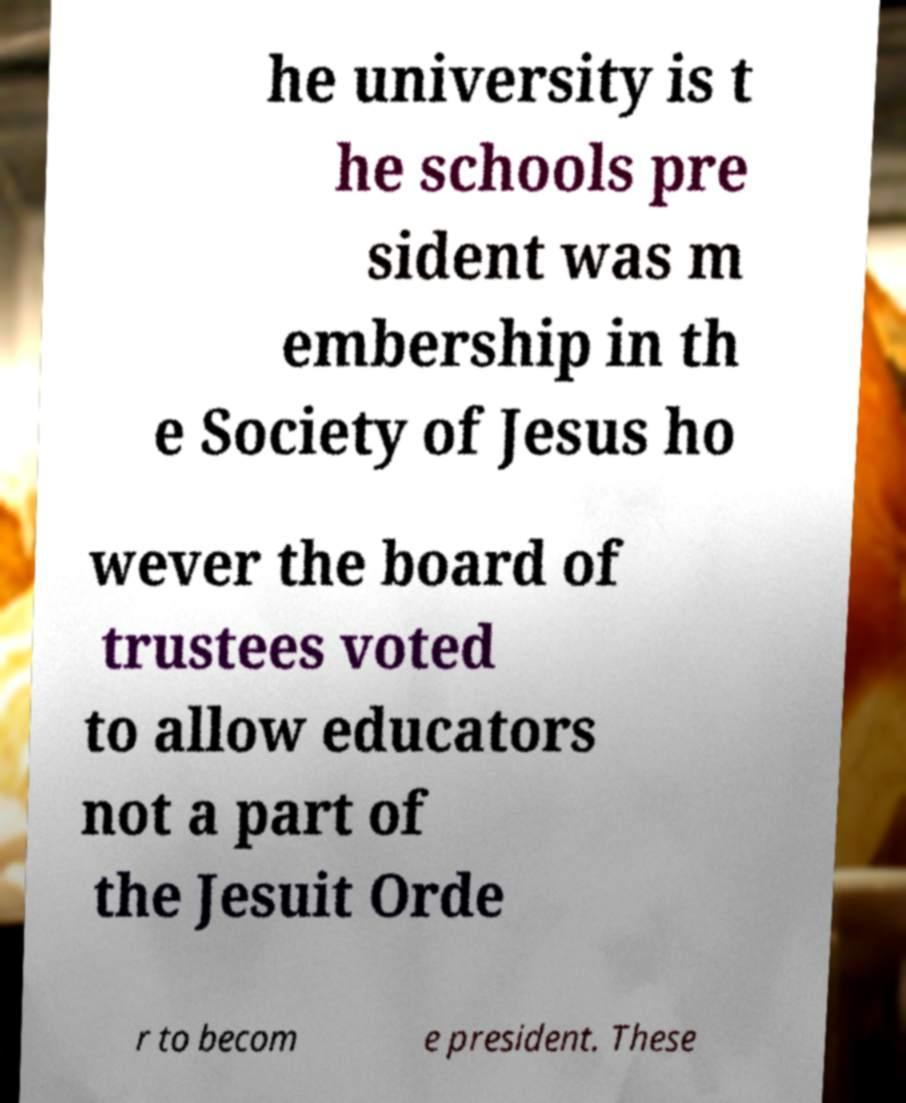What messages or text are displayed in this image? I need them in a readable, typed format. he university is t he schools pre sident was m embership in th e Society of Jesus ho wever the board of trustees voted to allow educators not a part of the Jesuit Orde r to becom e president. These 